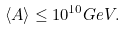Convert formula to latex. <formula><loc_0><loc_0><loc_500><loc_500>\langle A \rangle \leq 1 0 ^ { 1 0 } G e V .</formula> 